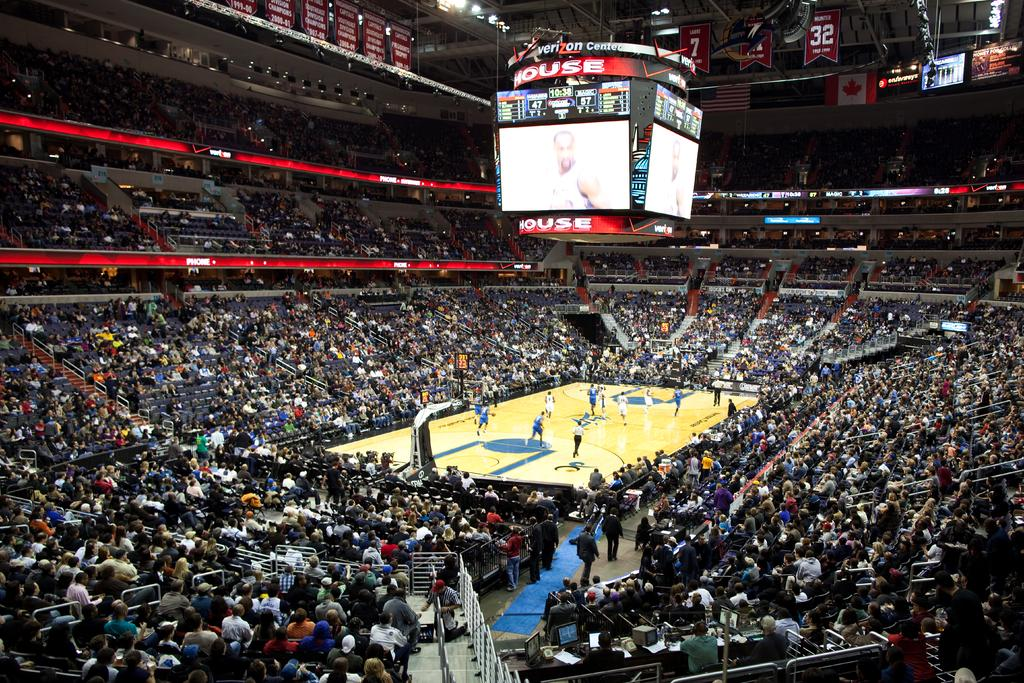<image>
Give a short and clear explanation of the subsequent image. A scoreboard for the Verizon Center is showcased during the basketball game 